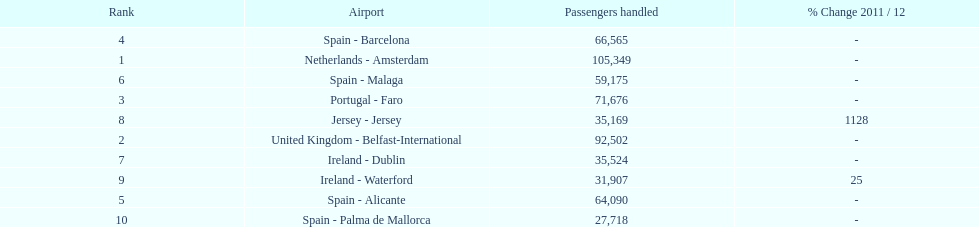How many passengers were handled in an airport in spain? 217,548. 